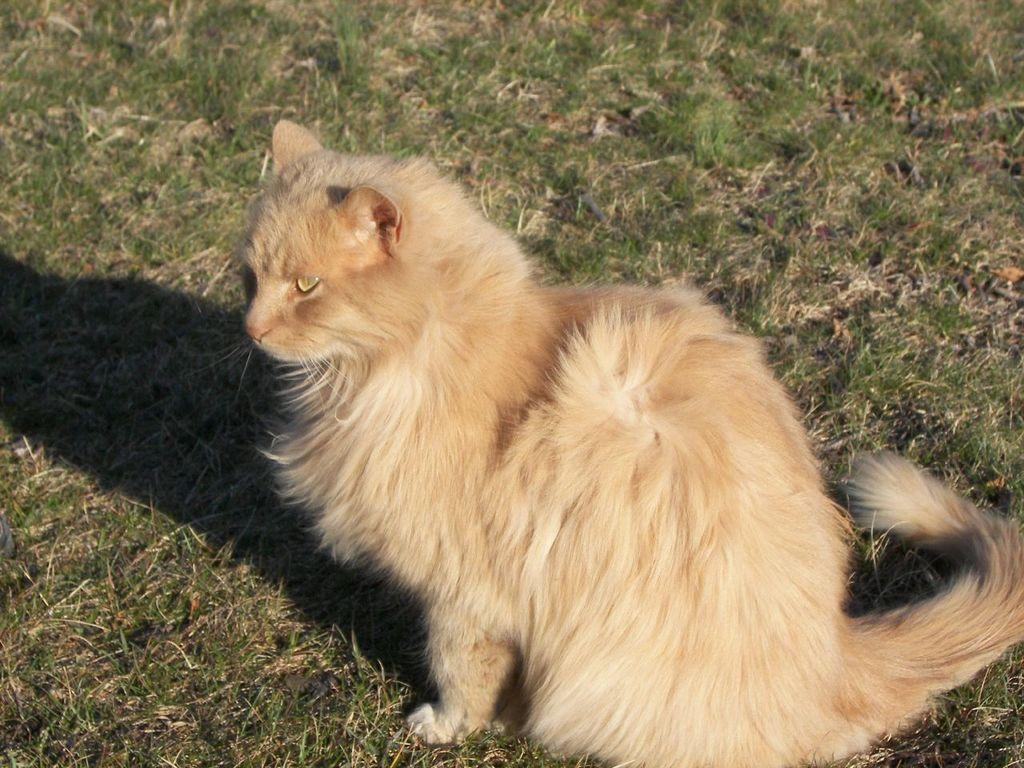Could you give a brief overview of what you see in this image? In the foreground of this image, there is a cat sitting on the grass. 